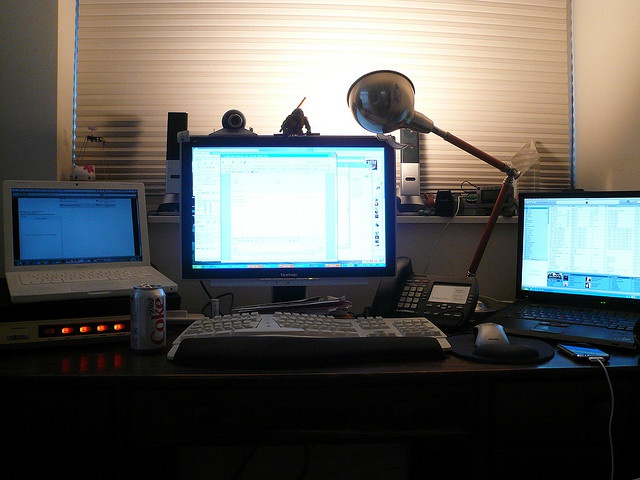Describe the objects in this image and their specific colors. I can see tv in darkgreen, white, navy, black, and cyan tones, laptop in darkgreen, lightblue, and black tones, laptop in darkgreen, blue, black, and gray tones, keyboard in darkgreen, gray, and black tones, and keyboard in darkgreen, black, navy, and blue tones in this image. 